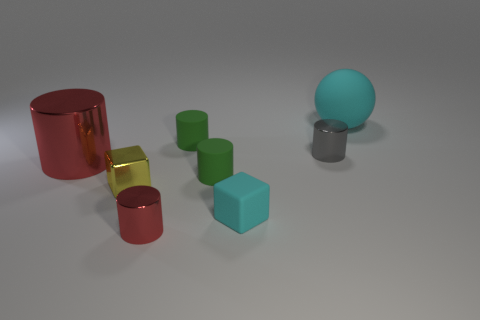Subtract all gray cylinders. How many cylinders are left? 4 Add 2 tiny metallic cubes. How many objects exist? 10 Subtract 3 cylinders. How many cylinders are left? 2 Subtract all gray cylinders. How many cylinders are left? 4 Subtract all yellow cylinders. Subtract all green cubes. How many cylinders are left? 5 Subtract all balls. How many objects are left? 7 Subtract 0 red balls. How many objects are left? 8 Subtract all small yellow shiny things. Subtract all tiny shiny cylinders. How many objects are left? 5 Add 7 spheres. How many spheres are left? 8 Add 4 tiny red metal blocks. How many tiny red metal blocks exist? 4 